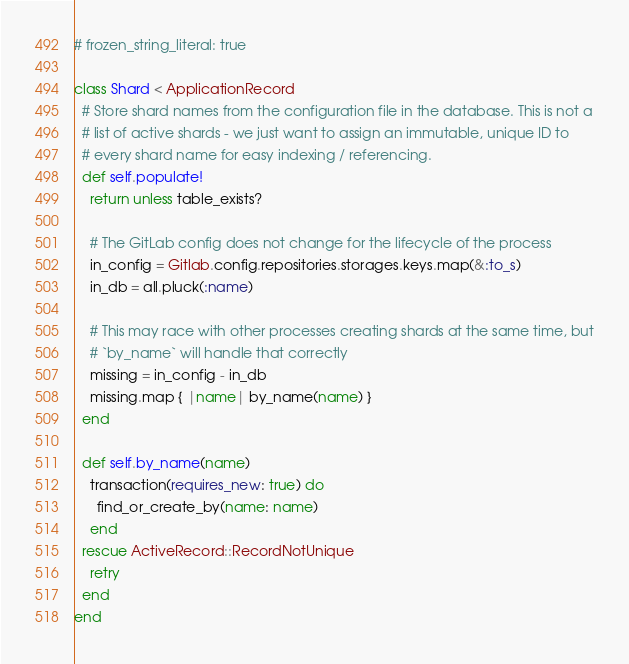<code> <loc_0><loc_0><loc_500><loc_500><_Ruby_># frozen_string_literal: true

class Shard < ApplicationRecord
  # Store shard names from the configuration file in the database. This is not a
  # list of active shards - we just want to assign an immutable, unique ID to
  # every shard name for easy indexing / referencing.
  def self.populate!
    return unless table_exists?

    # The GitLab config does not change for the lifecycle of the process
    in_config = Gitlab.config.repositories.storages.keys.map(&:to_s)
    in_db = all.pluck(:name)

    # This may race with other processes creating shards at the same time, but
    # `by_name` will handle that correctly
    missing = in_config - in_db
    missing.map { |name| by_name(name) }
  end

  def self.by_name(name)
    transaction(requires_new: true) do
      find_or_create_by(name: name)
    end
  rescue ActiveRecord::RecordNotUnique
    retry
  end
end
</code> 